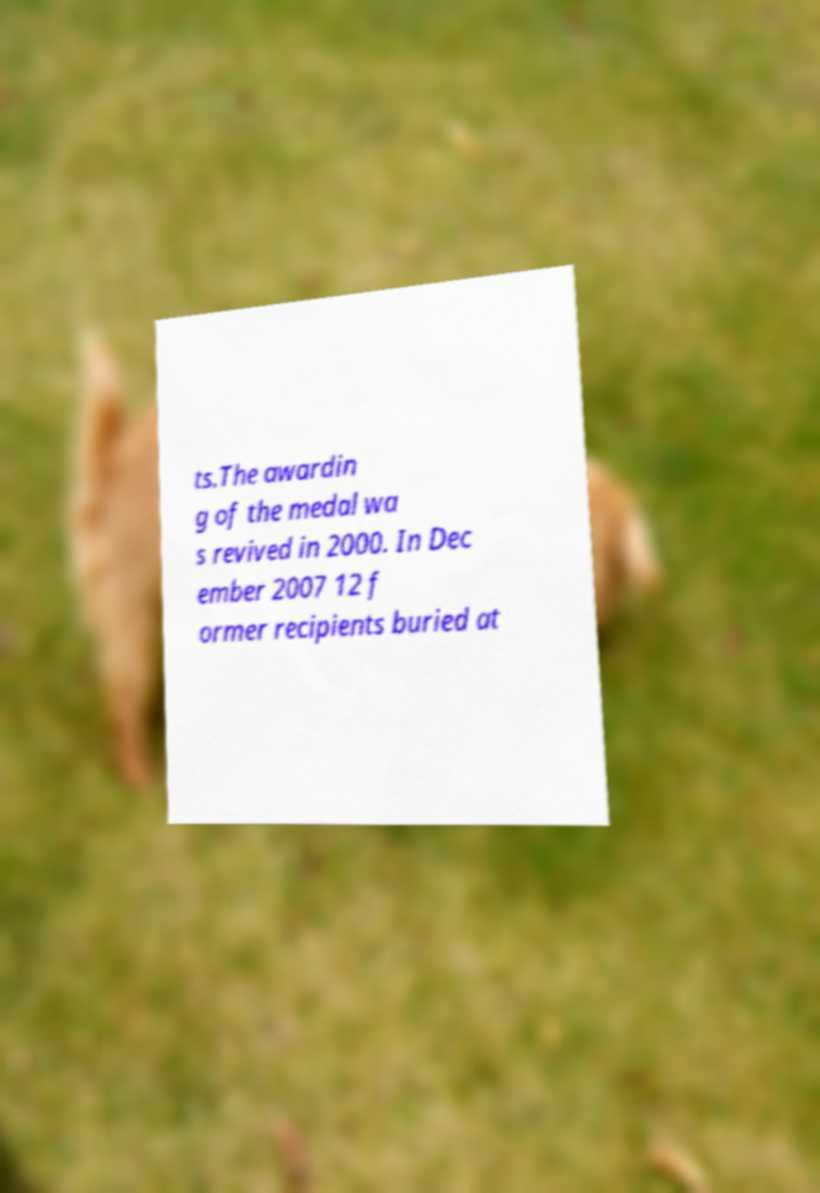I need the written content from this picture converted into text. Can you do that? ts.The awardin g of the medal wa s revived in 2000. In Dec ember 2007 12 f ormer recipients buried at 